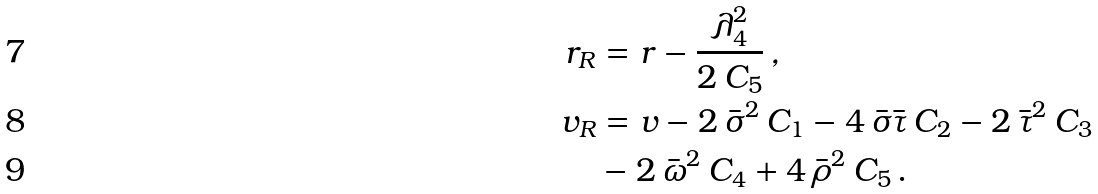Convert formula to latex. <formula><loc_0><loc_0><loc_500><loc_500>r _ { R } & = r - \frac { \lambda _ { 4 } ^ { 2 } } { 2 \, C _ { 5 } } \, , \\ v _ { R } & = v - 2 \, \bar { \sigma } ^ { 2 } \, C _ { 1 } - 4 \, \bar { \sigma } \bar { \tau } \, C _ { 2 } - 2 \, \bar { \tau } ^ { 2 } \, C _ { 3 } \\ & - 2 \, \bar { \omega } ^ { 2 } \, C _ { 4 } + 4 \, \bar { \rho } ^ { 2 } \, C _ { 5 } \, .</formula> 